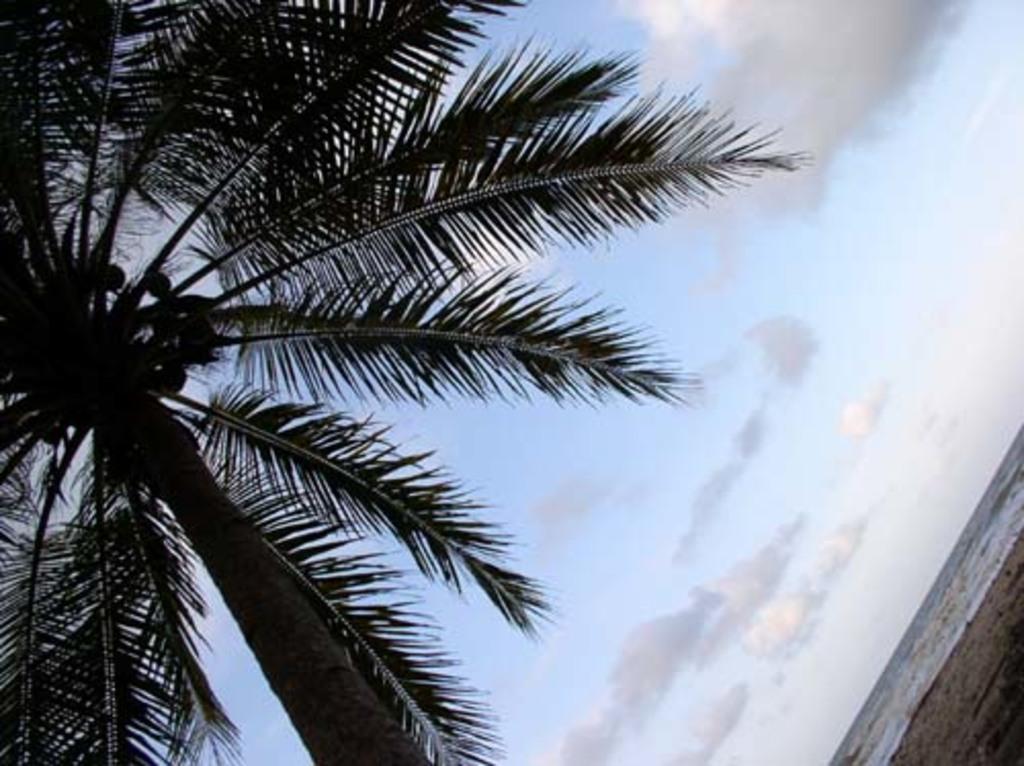How would you summarize this image in a sentence or two? In this image we can see a tree with some coconuts and also we can see the water, in the background, we can see the sky with clouds. 